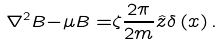Convert formula to latex. <formula><loc_0><loc_0><loc_500><loc_500>\nabla ^ { 2 } { B - } \mu { B = } \zeta \frac { 2 \pi } { 2 m } { \hat { z } } \delta \left ( { x } \right ) .</formula> 